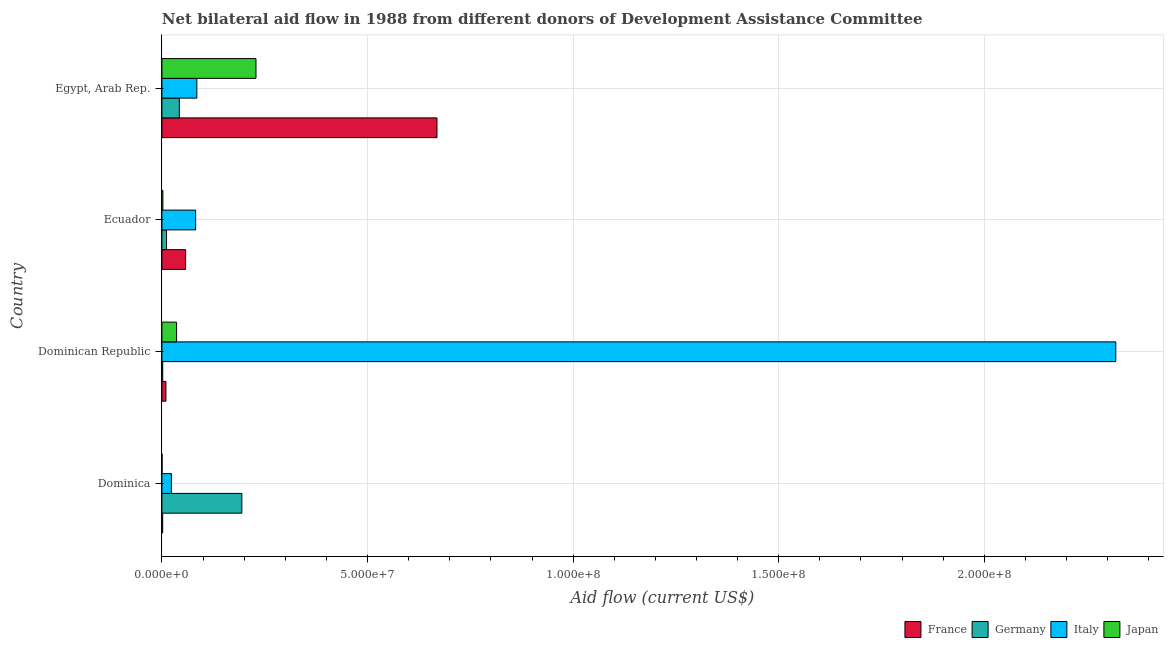How many groups of bars are there?
Keep it short and to the point. 4. Are the number of bars per tick equal to the number of legend labels?
Ensure brevity in your answer.  Yes. What is the label of the 4th group of bars from the top?
Offer a very short reply. Dominica. In how many cases, is the number of bars for a given country not equal to the number of legend labels?
Your response must be concise. 0. What is the amount of aid given by italy in Dominica?
Provide a succinct answer. 2.31e+06. Across all countries, what is the maximum amount of aid given by germany?
Your answer should be very brief. 1.94e+07. Across all countries, what is the minimum amount of aid given by france?
Provide a succinct answer. 1.90e+05. In which country was the amount of aid given by italy maximum?
Provide a succinct answer. Dominican Republic. In which country was the amount of aid given by japan minimum?
Offer a very short reply. Dominica. What is the total amount of aid given by germany in the graph?
Your response must be concise. 2.50e+07. What is the difference between the amount of aid given by japan in Dominica and that in Ecuador?
Offer a very short reply. -1.90e+05. What is the difference between the amount of aid given by germany in Dominican Republic and the amount of aid given by italy in Dominica?
Your response must be concise. -2.11e+06. What is the average amount of aid given by germany per country?
Keep it short and to the point. 6.25e+06. What is the difference between the amount of aid given by france and amount of aid given by italy in Dominica?
Provide a short and direct response. -2.12e+06. In how many countries, is the amount of aid given by france greater than 140000000 US$?
Your response must be concise. 0. What is the ratio of the amount of aid given by germany in Dominican Republic to that in Egypt, Arab Rep.?
Provide a succinct answer. 0.05. Is the amount of aid given by japan in Dominican Republic less than that in Egypt, Arab Rep.?
Your answer should be very brief. Yes. What is the difference between the highest and the second highest amount of aid given by japan?
Give a very brief answer. 1.93e+07. What is the difference between the highest and the lowest amount of aid given by italy?
Provide a succinct answer. 2.30e+08. In how many countries, is the amount of aid given by italy greater than the average amount of aid given by italy taken over all countries?
Give a very brief answer. 1. Is the sum of the amount of aid given by japan in Dominican Republic and Egypt, Arab Rep. greater than the maximum amount of aid given by france across all countries?
Keep it short and to the point. No. Is it the case that in every country, the sum of the amount of aid given by france and amount of aid given by japan is greater than the sum of amount of aid given by germany and amount of aid given by italy?
Offer a terse response. No. What does the 1st bar from the top in Dominica represents?
Provide a short and direct response. Japan. How many bars are there?
Make the answer very short. 16. How many countries are there in the graph?
Provide a succinct answer. 4. Does the graph contain any zero values?
Offer a very short reply. No. Does the graph contain grids?
Keep it short and to the point. Yes. How many legend labels are there?
Provide a short and direct response. 4. How are the legend labels stacked?
Ensure brevity in your answer.  Horizontal. What is the title of the graph?
Give a very brief answer. Net bilateral aid flow in 1988 from different donors of Development Assistance Committee. What is the label or title of the X-axis?
Keep it short and to the point. Aid flow (current US$). What is the Aid flow (current US$) in Germany in Dominica?
Provide a succinct answer. 1.94e+07. What is the Aid flow (current US$) of Italy in Dominica?
Give a very brief answer. 2.31e+06. What is the Aid flow (current US$) of Japan in Dominica?
Your answer should be very brief. 5.00e+04. What is the Aid flow (current US$) in France in Dominican Republic?
Keep it short and to the point. 9.80e+05. What is the Aid flow (current US$) of Italy in Dominican Republic?
Provide a short and direct response. 2.32e+08. What is the Aid flow (current US$) of Japan in Dominican Republic?
Your response must be concise. 3.57e+06. What is the Aid flow (current US$) in France in Ecuador?
Give a very brief answer. 5.77e+06. What is the Aid flow (current US$) in Germany in Ecuador?
Make the answer very short. 1.13e+06. What is the Aid flow (current US$) in Italy in Ecuador?
Give a very brief answer. 8.21e+06. What is the Aid flow (current US$) in France in Egypt, Arab Rep.?
Your answer should be compact. 6.69e+07. What is the Aid flow (current US$) in Germany in Egypt, Arab Rep.?
Give a very brief answer. 4.24e+06. What is the Aid flow (current US$) in Italy in Egypt, Arab Rep.?
Offer a terse response. 8.50e+06. What is the Aid flow (current US$) in Japan in Egypt, Arab Rep.?
Give a very brief answer. 2.29e+07. Across all countries, what is the maximum Aid flow (current US$) of France?
Your answer should be very brief. 6.69e+07. Across all countries, what is the maximum Aid flow (current US$) in Germany?
Offer a very short reply. 1.94e+07. Across all countries, what is the maximum Aid flow (current US$) of Italy?
Give a very brief answer. 2.32e+08. Across all countries, what is the maximum Aid flow (current US$) in Japan?
Offer a terse response. 2.29e+07. Across all countries, what is the minimum Aid flow (current US$) of France?
Provide a succinct answer. 1.90e+05. Across all countries, what is the minimum Aid flow (current US$) of Germany?
Provide a succinct answer. 2.00e+05. Across all countries, what is the minimum Aid flow (current US$) of Italy?
Give a very brief answer. 2.31e+06. What is the total Aid flow (current US$) in France in the graph?
Provide a succinct answer. 7.38e+07. What is the total Aid flow (current US$) in Germany in the graph?
Your response must be concise. 2.50e+07. What is the total Aid flow (current US$) of Italy in the graph?
Keep it short and to the point. 2.51e+08. What is the total Aid flow (current US$) of Japan in the graph?
Your answer should be very brief. 2.67e+07. What is the difference between the Aid flow (current US$) of France in Dominica and that in Dominican Republic?
Offer a terse response. -7.90e+05. What is the difference between the Aid flow (current US$) in Germany in Dominica and that in Dominican Republic?
Provide a succinct answer. 1.92e+07. What is the difference between the Aid flow (current US$) in Italy in Dominica and that in Dominican Republic?
Make the answer very short. -2.30e+08. What is the difference between the Aid flow (current US$) of Japan in Dominica and that in Dominican Republic?
Your answer should be compact. -3.52e+06. What is the difference between the Aid flow (current US$) in France in Dominica and that in Ecuador?
Your answer should be compact. -5.58e+06. What is the difference between the Aid flow (current US$) of Germany in Dominica and that in Ecuador?
Your answer should be very brief. 1.83e+07. What is the difference between the Aid flow (current US$) in Italy in Dominica and that in Ecuador?
Make the answer very short. -5.90e+06. What is the difference between the Aid flow (current US$) in France in Dominica and that in Egypt, Arab Rep.?
Provide a succinct answer. -6.67e+07. What is the difference between the Aid flow (current US$) of Germany in Dominica and that in Egypt, Arab Rep.?
Make the answer very short. 1.52e+07. What is the difference between the Aid flow (current US$) of Italy in Dominica and that in Egypt, Arab Rep.?
Give a very brief answer. -6.19e+06. What is the difference between the Aid flow (current US$) of Japan in Dominica and that in Egypt, Arab Rep.?
Your response must be concise. -2.28e+07. What is the difference between the Aid flow (current US$) in France in Dominican Republic and that in Ecuador?
Ensure brevity in your answer.  -4.79e+06. What is the difference between the Aid flow (current US$) of Germany in Dominican Republic and that in Ecuador?
Ensure brevity in your answer.  -9.30e+05. What is the difference between the Aid flow (current US$) of Italy in Dominican Republic and that in Ecuador?
Your answer should be very brief. 2.24e+08. What is the difference between the Aid flow (current US$) in Japan in Dominican Republic and that in Ecuador?
Your answer should be very brief. 3.33e+06. What is the difference between the Aid flow (current US$) of France in Dominican Republic and that in Egypt, Arab Rep.?
Give a very brief answer. -6.59e+07. What is the difference between the Aid flow (current US$) in Germany in Dominican Republic and that in Egypt, Arab Rep.?
Make the answer very short. -4.04e+06. What is the difference between the Aid flow (current US$) in Italy in Dominican Republic and that in Egypt, Arab Rep.?
Make the answer very short. 2.23e+08. What is the difference between the Aid flow (current US$) of Japan in Dominican Republic and that in Egypt, Arab Rep.?
Give a very brief answer. -1.93e+07. What is the difference between the Aid flow (current US$) in France in Ecuador and that in Egypt, Arab Rep.?
Your answer should be compact. -6.11e+07. What is the difference between the Aid flow (current US$) in Germany in Ecuador and that in Egypt, Arab Rep.?
Make the answer very short. -3.11e+06. What is the difference between the Aid flow (current US$) of Japan in Ecuador and that in Egypt, Arab Rep.?
Provide a short and direct response. -2.26e+07. What is the difference between the Aid flow (current US$) in France in Dominica and the Aid flow (current US$) in Italy in Dominican Republic?
Your answer should be very brief. -2.32e+08. What is the difference between the Aid flow (current US$) in France in Dominica and the Aid flow (current US$) in Japan in Dominican Republic?
Your response must be concise. -3.38e+06. What is the difference between the Aid flow (current US$) in Germany in Dominica and the Aid flow (current US$) in Italy in Dominican Republic?
Provide a succinct answer. -2.13e+08. What is the difference between the Aid flow (current US$) of Germany in Dominica and the Aid flow (current US$) of Japan in Dominican Republic?
Make the answer very short. 1.59e+07. What is the difference between the Aid flow (current US$) in Italy in Dominica and the Aid flow (current US$) in Japan in Dominican Republic?
Make the answer very short. -1.26e+06. What is the difference between the Aid flow (current US$) of France in Dominica and the Aid flow (current US$) of Germany in Ecuador?
Give a very brief answer. -9.40e+05. What is the difference between the Aid flow (current US$) in France in Dominica and the Aid flow (current US$) in Italy in Ecuador?
Offer a very short reply. -8.02e+06. What is the difference between the Aid flow (current US$) of Germany in Dominica and the Aid flow (current US$) of Italy in Ecuador?
Give a very brief answer. 1.12e+07. What is the difference between the Aid flow (current US$) in Germany in Dominica and the Aid flow (current US$) in Japan in Ecuador?
Your response must be concise. 1.92e+07. What is the difference between the Aid flow (current US$) in Italy in Dominica and the Aid flow (current US$) in Japan in Ecuador?
Provide a short and direct response. 2.07e+06. What is the difference between the Aid flow (current US$) in France in Dominica and the Aid flow (current US$) in Germany in Egypt, Arab Rep.?
Provide a short and direct response. -4.05e+06. What is the difference between the Aid flow (current US$) of France in Dominica and the Aid flow (current US$) of Italy in Egypt, Arab Rep.?
Provide a succinct answer. -8.31e+06. What is the difference between the Aid flow (current US$) in France in Dominica and the Aid flow (current US$) in Japan in Egypt, Arab Rep.?
Provide a succinct answer. -2.27e+07. What is the difference between the Aid flow (current US$) of Germany in Dominica and the Aid flow (current US$) of Italy in Egypt, Arab Rep.?
Provide a short and direct response. 1.09e+07. What is the difference between the Aid flow (current US$) of Germany in Dominica and the Aid flow (current US$) of Japan in Egypt, Arab Rep.?
Offer a very short reply. -3.44e+06. What is the difference between the Aid flow (current US$) of Italy in Dominica and the Aid flow (current US$) of Japan in Egypt, Arab Rep.?
Provide a succinct answer. -2.06e+07. What is the difference between the Aid flow (current US$) in France in Dominican Republic and the Aid flow (current US$) in Germany in Ecuador?
Provide a short and direct response. -1.50e+05. What is the difference between the Aid flow (current US$) of France in Dominican Republic and the Aid flow (current US$) of Italy in Ecuador?
Provide a succinct answer. -7.23e+06. What is the difference between the Aid flow (current US$) of France in Dominican Republic and the Aid flow (current US$) of Japan in Ecuador?
Ensure brevity in your answer.  7.40e+05. What is the difference between the Aid flow (current US$) in Germany in Dominican Republic and the Aid flow (current US$) in Italy in Ecuador?
Make the answer very short. -8.01e+06. What is the difference between the Aid flow (current US$) of Germany in Dominican Republic and the Aid flow (current US$) of Japan in Ecuador?
Your response must be concise. -4.00e+04. What is the difference between the Aid flow (current US$) in Italy in Dominican Republic and the Aid flow (current US$) in Japan in Ecuador?
Make the answer very short. 2.32e+08. What is the difference between the Aid flow (current US$) in France in Dominican Republic and the Aid flow (current US$) in Germany in Egypt, Arab Rep.?
Your response must be concise. -3.26e+06. What is the difference between the Aid flow (current US$) of France in Dominican Republic and the Aid flow (current US$) of Italy in Egypt, Arab Rep.?
Provide a short and direct response. -7.52e+06. What is the difference between the Aid flow (current US$) of France in Dominican Republic and the Aid flow (current US$) of Japan in Egypt, Arab Rep.?
Offer a terse response. -2.19e+07. What is the difference between the Aid flow (current US$) of Germany in Dominican Republic and the Aid flow (current US$) of Italy in Egypt, Arab Rep.?
Your answer should be very brief. -8.30e+06. What is the difference between the Aid flow (current US$) in Germany in Dominican Republic and the Aid flow (current US$) in Japan in Egypt, Arab Rep.?
Your answer should be very brief. -2.27e+07. What is the difference between the Aid flow (current US$) of Italy in Dominican Republic and the Aid flow (current US$) of Japan in Egypt, Arab Rep.?
Your response must be concise. 2.09e+08. What is the difference between the Aid flow (current US$) in France in Ecuador and the Aid flow (current US$) in Germany in Egypt, Arab Rep.?
Ensure brevity in your answer.  1.53e+06. What is the difference between the Aid flow (current US$) in France in Ecuador and the Aid flow (current US$) in Italy in Egypt, Arab Rep.?
Your answer should be very brief. -2.73e+06. What is the difference between the Aid flow (current US$) in France in Ecuador and the Aid flow (current US$) in Japan in Egypt, Arab Rep.?
Your answer should be compact. -1.71e+07. What is the difference between the Aid flow (current US$) of Germany in Ecuador and the Aid flow (current US$) of Italy in Egypt, Arab Rep.?
Your response must be concise. -7.37e+06. What is the difference between the Aid flow (current US$) of Germany in Ecuador and the Aid flow (current US$) of Japan in Egypt, Arab Rep.?
Your answer should be compact. -2.18e+07. What is the difference between the Aid flow (current US$) of Italy in Ecuador and the Aid flow (current US$) of Japan in Egypt, Arab Rep.?
Your response must be concise. -1.47e+07. What is the average Aid flow (current US$) in France per country?
Your response must be concise. 1.85e+07. What is the average Aid flow (current US$) of Germany per country?
Offer a very short reply. 6.25e+06. What is the average Aid flow (current US$) of Italy per country?
Provide a short and direct response. 6.27e+07. What is the average Aid flow (current US$) in Japan per country?
Ensure brevity in your answer.  6.68e+06. What is the difference between the Aid flow (current US$) of France and Aid flow (current US$) of Germany in Dominica?
Ensure brevity in your answer.  -1.92e+07. What is the difference between the Aid flow (current US$) in France and Aid flow (current US$) in Italy in Dominica?
Ensure brevity in your answer.  -2.12e+06. What is the difference between the Aid flow (current US$) in France and Aid flow (current US$) in Japan in Dominica?
Ensure brevity in your answer.  1.40e+05. What is the difference between the Aid flow (current US$) in Germany and Aid flow (current US$) in Italy in Dominica?
Your answer should be compact. 1.71e+07. What is the difference between the Aid flow (current US$) of Germany and Aid flow (current US$) of Japan in Dominica?
Your response must be concise. 1.94e+07. What is the difference between the Aid flow (current US$) of Italy and Aid flow (current US$) of Japan in Dominica?
Provide a succinct answer. 2.26e+06. What is the difference between the Aid flow (current US$) in France and Aid flow (current US$) in Germany in Dominican Republic?
Make the answer very short. 7.80e+05. What is the difference between the Aid flow (current US$) of France and Aid flow (current US$) of Italy in Dominican Republic?
Offer a terse response. -2.31e+08. What is the difference between the Aid flow (current US$) of France and Aid flow (current US$) of Japan in Dominican Republic?
Give a very brief answer. -2.59e+06. What is the difference between the Aid flow (current US$) of Germany and Aid flow (current US$) of Italy in Dominican Republic?
Make the answer very short. -2.32e+08. What is the difference between the Aid flow (current US$) of Germany and Aid flow (current US$) of Japan in Dominican Republic?
Provide a succinct answer. -3.37e+06. What is the difference between the Aid flow (current US$) of Italy and Aid flow (current US$) of Japan in Dominican Republic?
Keep it short and to the point. 2.28e+08. What is the difference between the Aid flow (current US$) of France and Aid flow (current US$) of Germany in Ecuador?
Give a very brief answer. 4.64e+06. What is the difference between the Aid flow (current US$) in France and Aid flow (current US$) in Italy in Ecuador?
Your answer should be very brief. -2.44e+06. What is the difference between the Aid flow (current US$) in France and Aid flow (current US$) in Japan in Ecuador?
Your response must be concise. 5.53e+06. What is the difference between the Aid flow (current US$) of Germany and Aid flow (current US$) of Italy in Ecuador?
Your answer should be compact. -7.08e+06. What is the difference between the Aid flow (current US$) in Germany and Aid flow (current US$) in Japan in Ecuador?
Give a very brief answer. 8.90e+05. What is the difference between the Aid flow (current US$) of Italy and Aid flow (current US$) of Japan in Ecuador?
Your response must be concise. 7.97e+06. What is the difference between the Aid flow (current US$) in France and Aid flow (current US$) in Germany in Egypt, Arab Rep.?
Provide a succinct answer. 6.26e+07. What is the difference between the Aid flow (current US$) of France and Aid flow (current US$) of Italy in Egypt, Arab Rep.?
Provide a short and direct response. 5.84e+07. What is the difference between the Aid flow (current US$) in France and Aid flow (current US$) in Japan in Egypt, Arab Rep.?
Offer a very short reply. 4.40e+07. What is the difference between the Aid flow (current US$) of Germany and Aid flow (current US$) of Italy in Egypt, Arab Rep.?
Provide a succinct answer. -4.26e+06. What is the difference between the Aid flow (current US$) of Germany and Aid flow (current US$) of Japan in Egypt, Arab Rep.?
Your response must be concise. -1.86e+07. What is the difference between the Aid flow (current US$) of Italy and Aid flow (current US$) of Japan in Egypt, Arab Rep.?
Ensure brevity in your answer.  -1.44e+07. What is the ratio of the Aid flow (current US$) in France in Dominica to that in Dominican Republic?
Keep it short and to the point. 0.19. What is the ratio of the Aid flow (current US$) in Germany in Dominica to that in Dominican Republic?
Your response must be concise. 97.2. What is the ratio of the Aid flow (current US$) of Italy in Dominica to that in Dominican Republic?
Ensure brevity in your answer.  0.01. What is the ratio of the Aid flow (current US$) in Japan in Dominica to that in Dominican Republic?
Give a very brief answer. 0.01. What is the ratio of the Aid flow (current US$) of France in Dominica to that in Ecuador?
Offer a very short reply. 0.03. What is the ratio of the Aid flow (current US$) of Germany in Dominica to that in Ecuador?
Ensure brevity in your answer.  17.2. What is the ratio of the Aid flow (current US$) in Italy in Dominica to that in Ecuador?
Give a very brief answer. 0.28. What is the ratio of the Aid flow (current US$) of Japan in Dominica to that in Ecuador?
Offer a terse response. 0.21. What is the ratio of the Aid flow (current US$) in France in Dominica to that in Egypt, Arab Rep.?
Offer a terse response. 0. What is the ratio of the Aid flow (current US$) in Germany in Dominica to that in Egypt, Arab Rep.?
Make the answer very short. 4.58. What is the ratio of the Aid flow (current US$) of Italy in Dominica to that in Egypt, Arab Rep.?
Offer a very short reply. 0.27. What is the ratio of the Aid flow (current US$) in Japan in Dominica to that in Egypt, Arab Rep.?
Keep it short and to the point. 0. What is the ratio of the Aid flow (current US$) of France in Dominican Republic to that in Ecuador?
Give a very brief answer. 0.17. What is the ratio of the Aid flow (current US$) of Germany in Dominican Republic to that in Ecuador?
Offer a terse response. 0.18. What is the ratio of the Aid flow (current US$) of Italy in Dominican Republic to that in Ecuador?
Your answer should be compact. 28.25. What is the ratio of the Aid flow (current US$) of Japan in Dominican Republic to that in Ecuador?
Ensure brevity in your answer.  14.88. What is the ratio of the Aid flow (current US$) of France in Dominican Republic to that in Egypt, Arab Rep.?
Offer a very short reply. 0.01. What is the ratio of the Aid flow (current US$) in Germany in Dominican Republic to that in Egypt, Arab Rep.?
Ensure brevity in your answer.  0.05. What is the ratio of the Aid flow (current US$) in Italy in Dominican Republic to that in Egypt, Arab Rep.?
Keep it short and to the point. 27.29. What is the ratio of the Aid flow (current US$) in Japan in Dominican Republic to that in Egypt, Arab Rep.?
Provide a succinct answer. 0.16. What is the ratio of the Aid flow (current US$) in France in Ecuador to that in Egypt, Arab Rep.?
Offer a terse response. 0.09. What is the ratio of the Aid flow (current US$) in Germany in Ecuador to that in Egypt, Arab Rep.?
Your response must be concise. 0.27. What is the ratio of the Aid flow (current US$) in Italy in Ecuador to that in Egypt, Arab Rep.?
Your response must be concise. 0.97. What is the ratio of the Aid flow (current US$) of Japan in Ecuador to that in Egypt, Arab Rep.?
Your response must be concise. 0.01. What is the difference between the highest and the second highest Aid flow (current US$) in France?
Your answer should be very brief. 6.11e+07. What is the difference between the highest and the second highest Aid flow (current US$) in Germany?
Offer a very short reply. 1.52e+07. What is the difference between the highest and the second highest Aid flow (current US$) of Italy?
Your response must be concise. 2.23e+08. What is the difference between the highest and the second highest Aid flow (current US$) of Japan?
Provide a short and direct response. 1.93e+07. What is the difference between the highest and the lowest Aid flow (current US$) of France?
Make the answer very short. 6.67e+07. What is the difference between the highest and the lowest Aid flow (current US$) of Germany?
Offer a very short reply. 1.92e+07. What is the difference between the highest and the lowest Aid flow (current US$) of Italy?
Offer a terse response. 2.30e+08. What is the difference between the highest and the lowest Aid flow (current US$) of Japan?
Provide a short and direct response. 2.28e+07. 